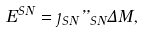<formula> <loc_0><loc_0><loc_500><loc_500>E ^ { S N } = \eta _ { S N } \varepsilon _ { S N } \Delta M ,</formula> 